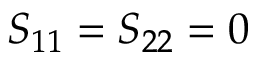<formula> <loc_0><loc_0><loc_500><loc_500>S _ { 1 1 } = S _ { 2 2 } = 0</formula> 